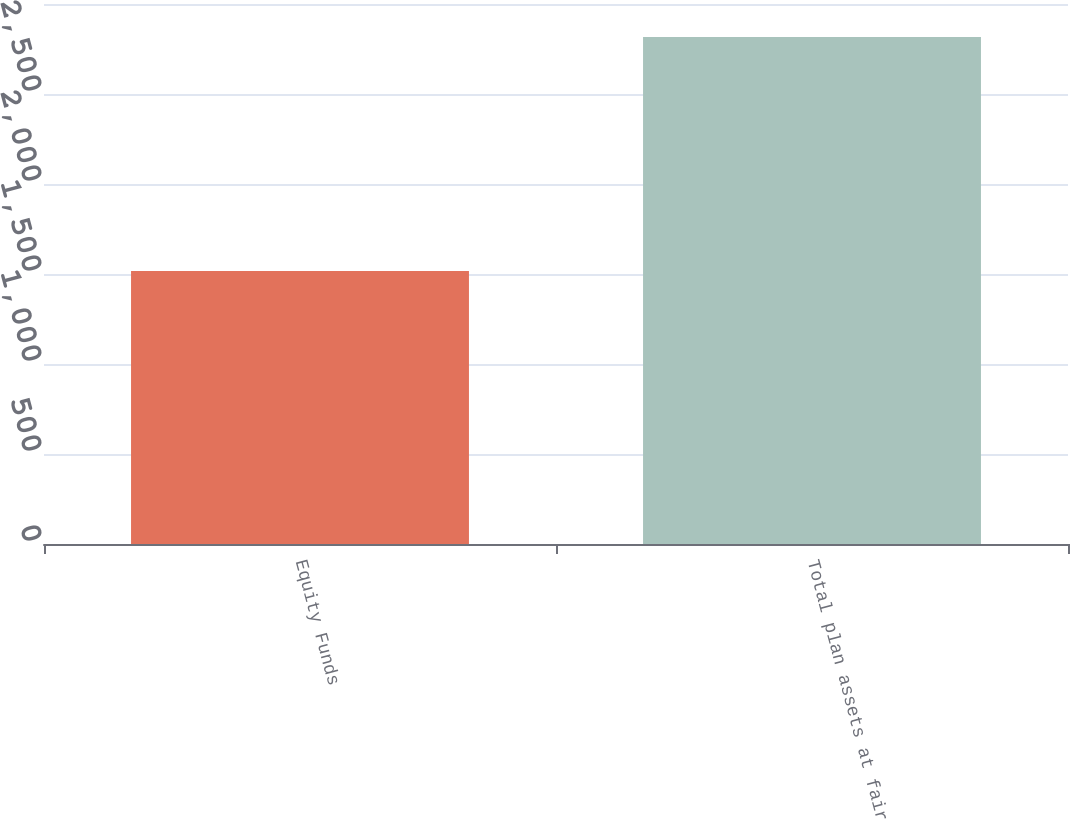<chart> <loc_0><loc_0><loc_500><loc_500><bar_chart><fcel>Equity Funds<fcel>Total plan assets at fair<nl><fcel>1516<fcel>2816<nl></chart> 